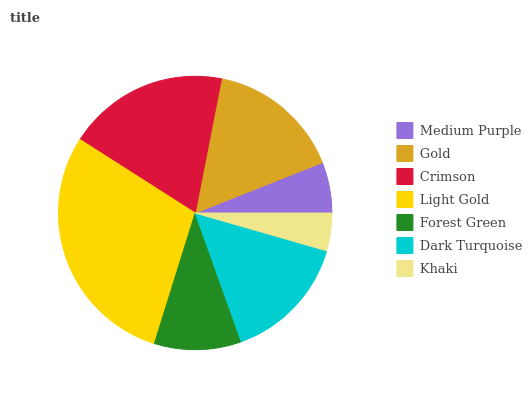Is Khaki the minimum?
Answer yes or no. Yes. Is Light Gold the maximum?
Answer yes or no. Yes. Is Gold the minimum?
Answer yes or no. No. Is Gold the maximum?
Answer yes or no. No. Is Gold greater than Medium Purple?
Answer yes or no. Yes. Is Medium Purple less than Gold?
Answer yes or no. Yes. Is Medium Purple greater than Gold?
Answer yes or no. No. Is Gold less than Medium Purple?
Answer yes or no. No. Is Dark Turquoise the high median?
Answer yes or no. Yes. Is Dark Turquoise the low median?
Answer yes or no. Yes. Is Gold the high median?
Answer yes or no. No. Is Forest Green the low median?
Answer yes or no. No. 